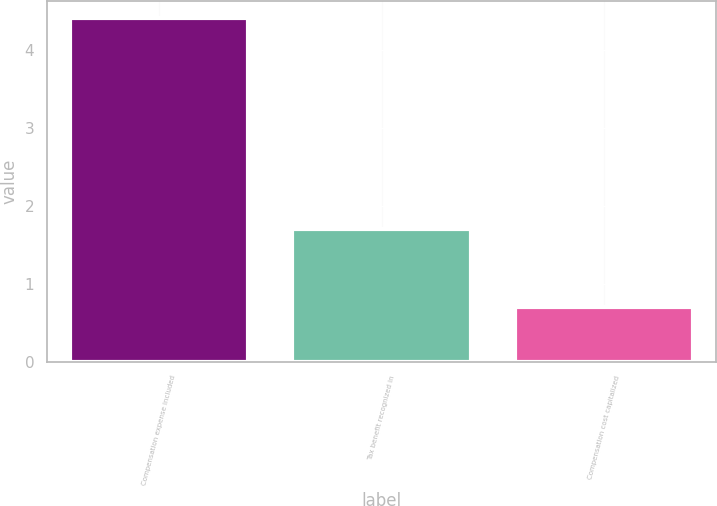Convert chart to OTSL. <chart><loc_0><loc_0><loc_500><loc_500><bar_chart><fcel>Compensation expense included<fcel>Tax benefit recognized in<fcel>Compensation cost capitalized<nl><fcel>4.4<fcel>1.7<fcel>0.7<nl></chart> 